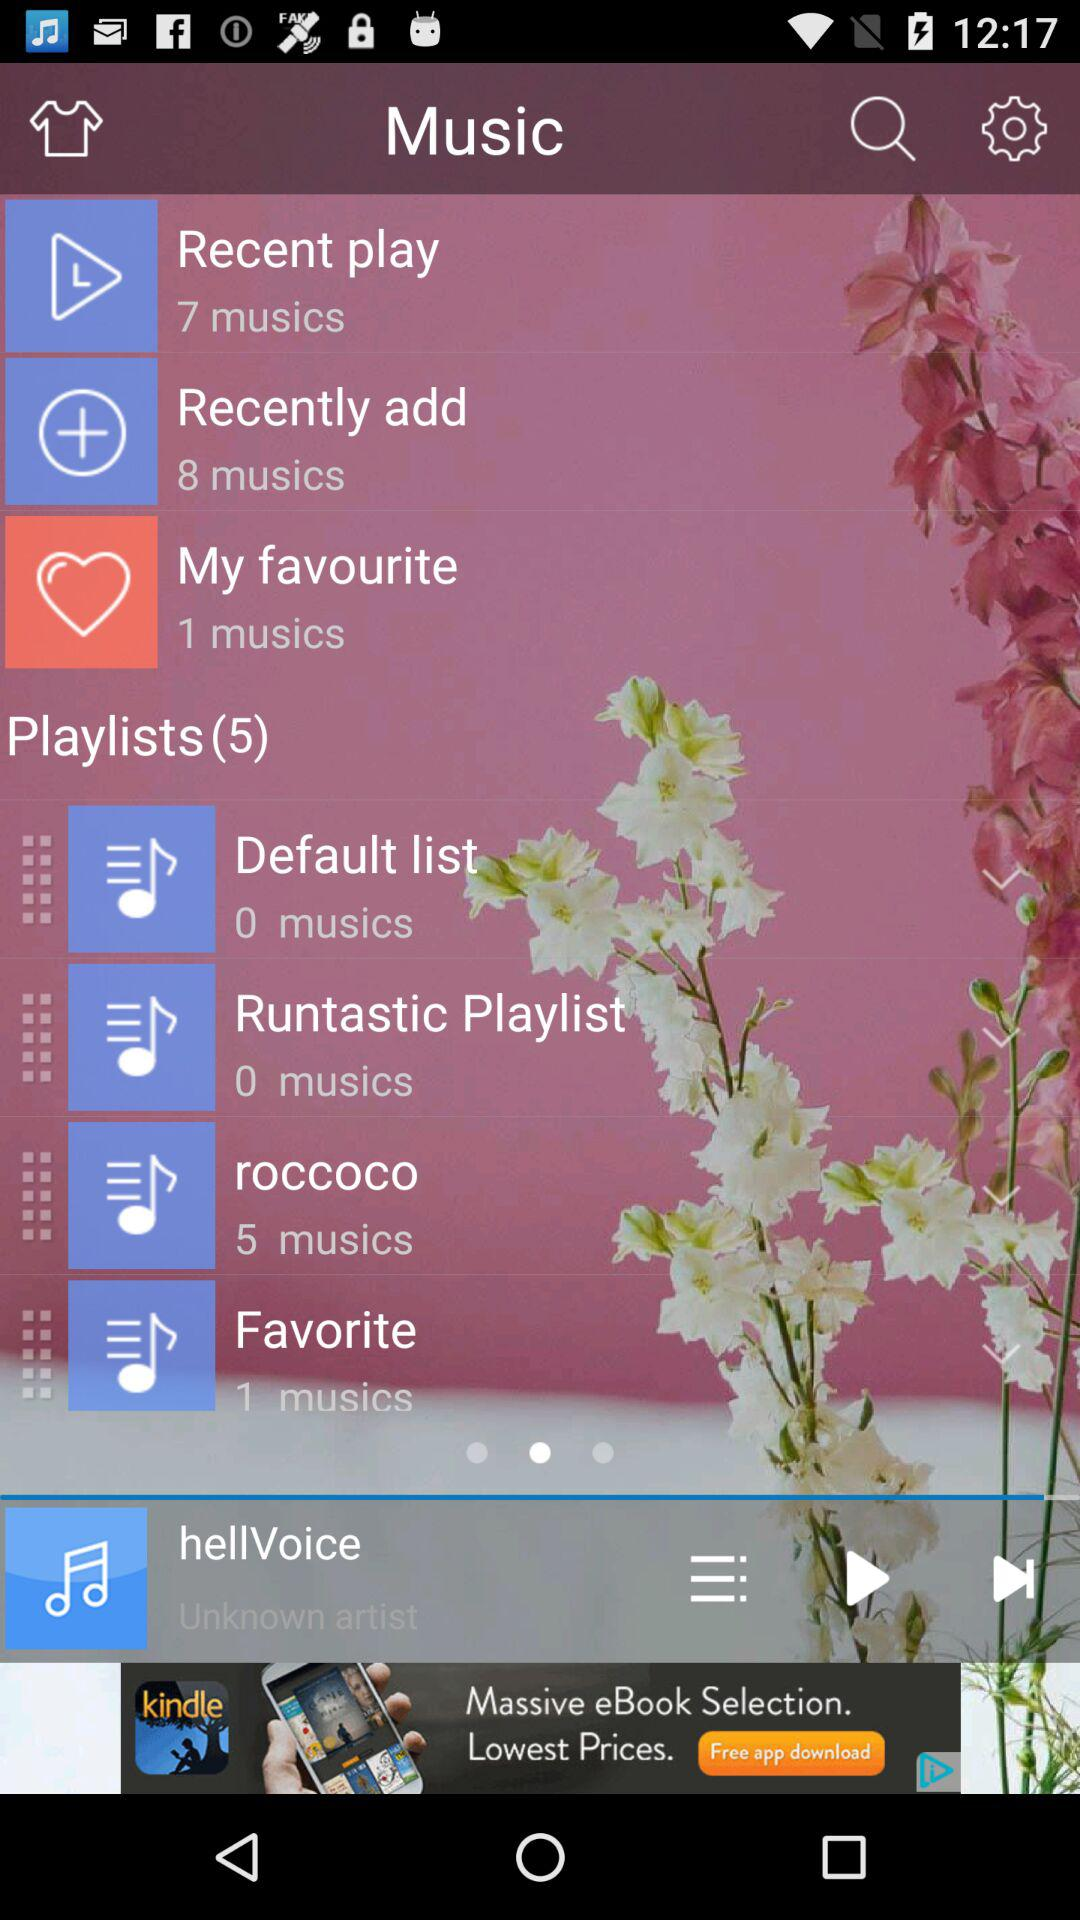What song is currently playing? The currently playing song is "hellVoice". 